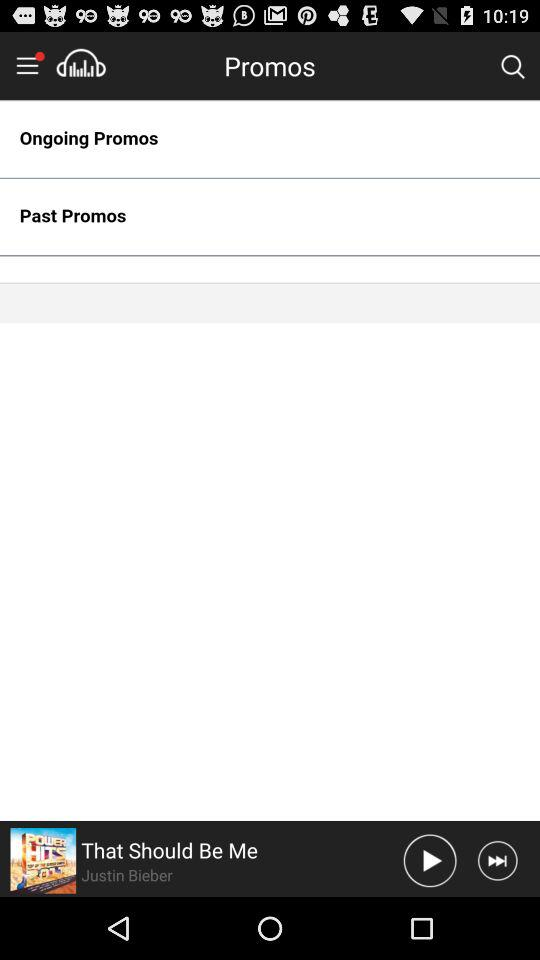What is the singer name of the current playing song? The singer name of the current playing song is Justin Bieber. 